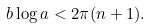Convert formula to latex. <formula><loc_0><loc_0><loc_500><loc_500>b \log a < 2 \pi ( n + 1 ) .</formula> 